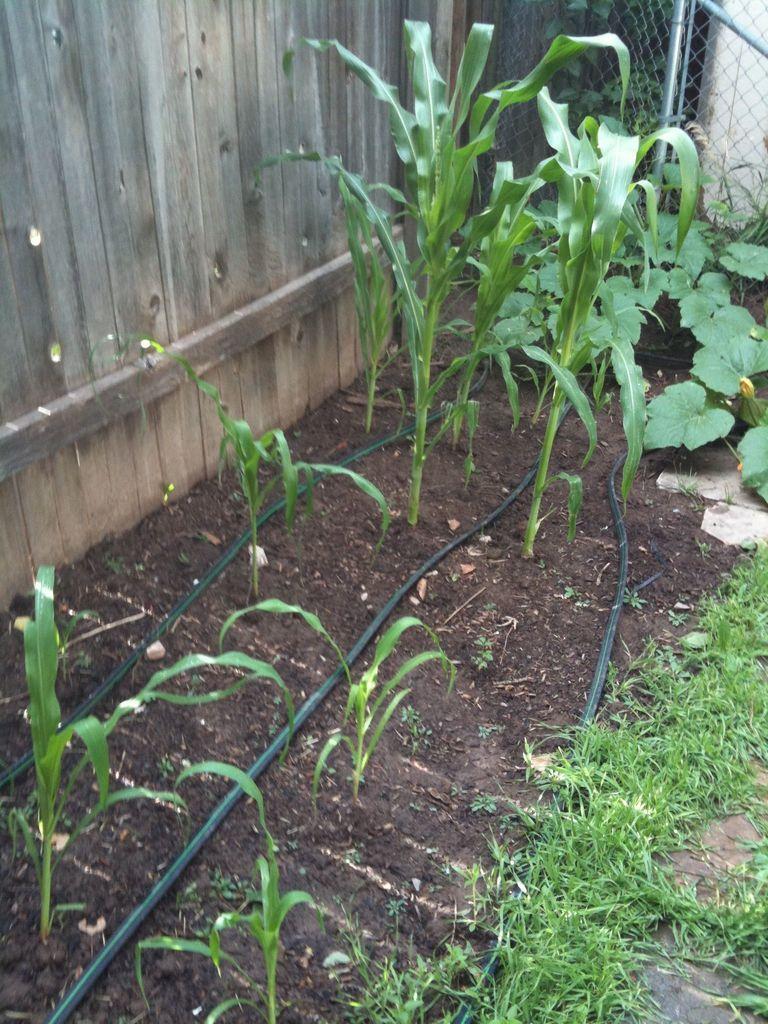In one or two sentences, can you explain what this image depicts? In this image there are plants and pipes, in the background there is a wooden wall, in the top right corner there is fencing. 